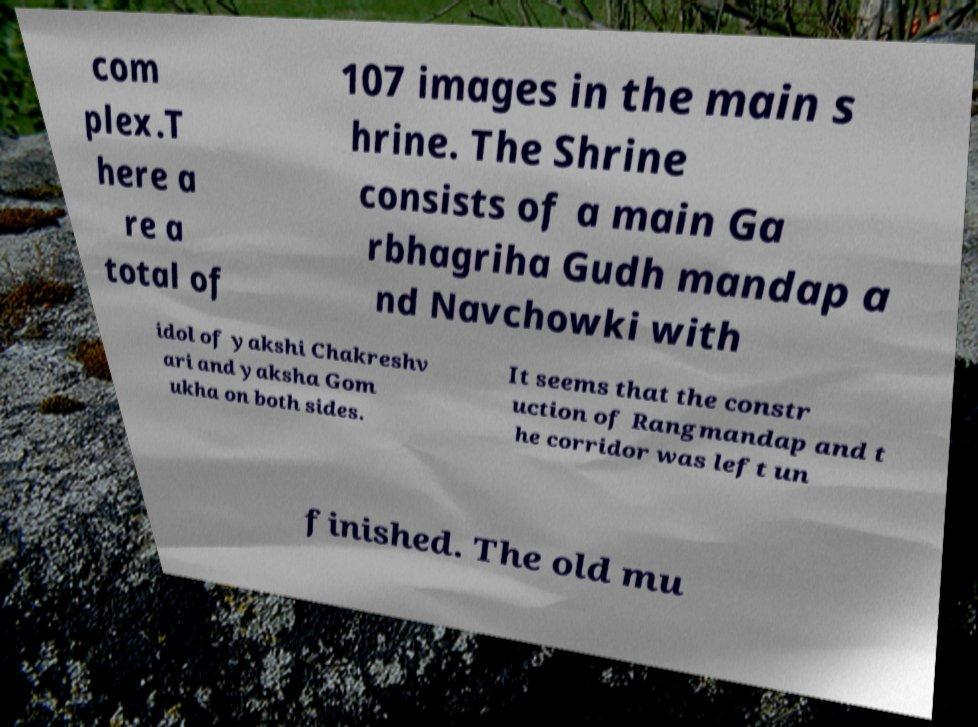What messages or text are displayed in this image? I need them in a readable, typed format. com plex.T here a re a total of 107 images in the main s hrine. The Shrine consists of a main Ga rbhagriha Gudh mandap a nd Navchowki with idol of yakshi Chakreshv ari and yaksha Gom ukha on both sides. It seems that the constr uction of Rangmandap and t he corridor was left un finished. The old mu 